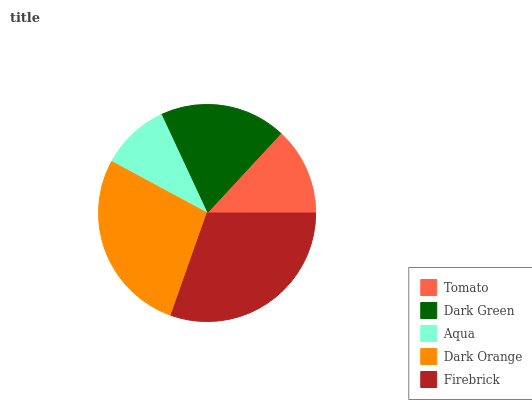Is Aqua the minimum?
Answer yes or no. Yes. Is Firebrick the maximum?
Answer yes or no. Yes. Is Dark Green the minimum?
Answer yes or no. No. Is Dark Green the maximum?
Answer yes or no. No. Is Dark Green greater than Tomato?
Answer yes or no. Yes. Is Tomato less than Dark Green?
Answer yes or no. Yes. Is Tomato greater than Dark Green?
Answer yes or no. No. Is Dark Green less than Tomato?
Answer yes or no. No. Is Dark Green the high median?
Answer yes or no. Yes. Is Dark Green the low median?
Answer yes or no. Yes. Is Aqua the high median?
Answer yes or no. No. Is Aqua the low median?
Answer yes or no. No. 